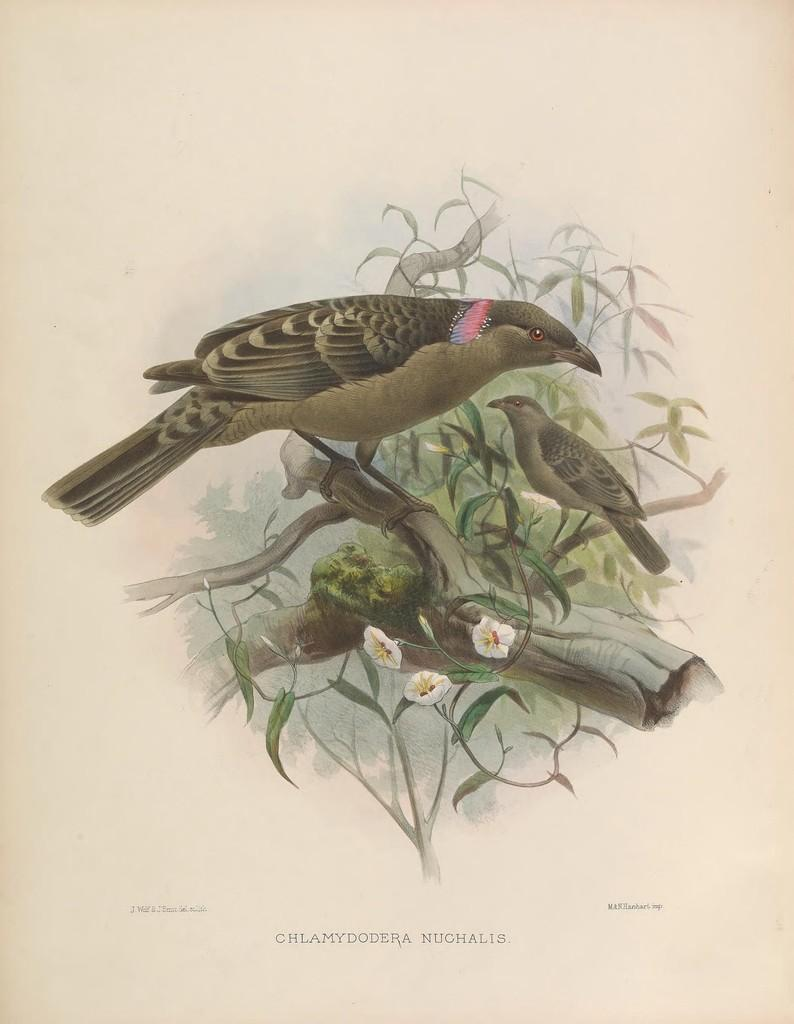What type of artwork is depicted in the image? The image is a painting. What animals can be seen in the painting? There are birds in the painting. Where are the birds located in the painting? The birds are on a branch. What other elements are present in the painting? There are flowers in the painting. What type of competition is taking place between the birds in the painting? There is no competition depicted between the birds in the painting. Can you see any bombs in the painting? There are no bombs present in the painting. 